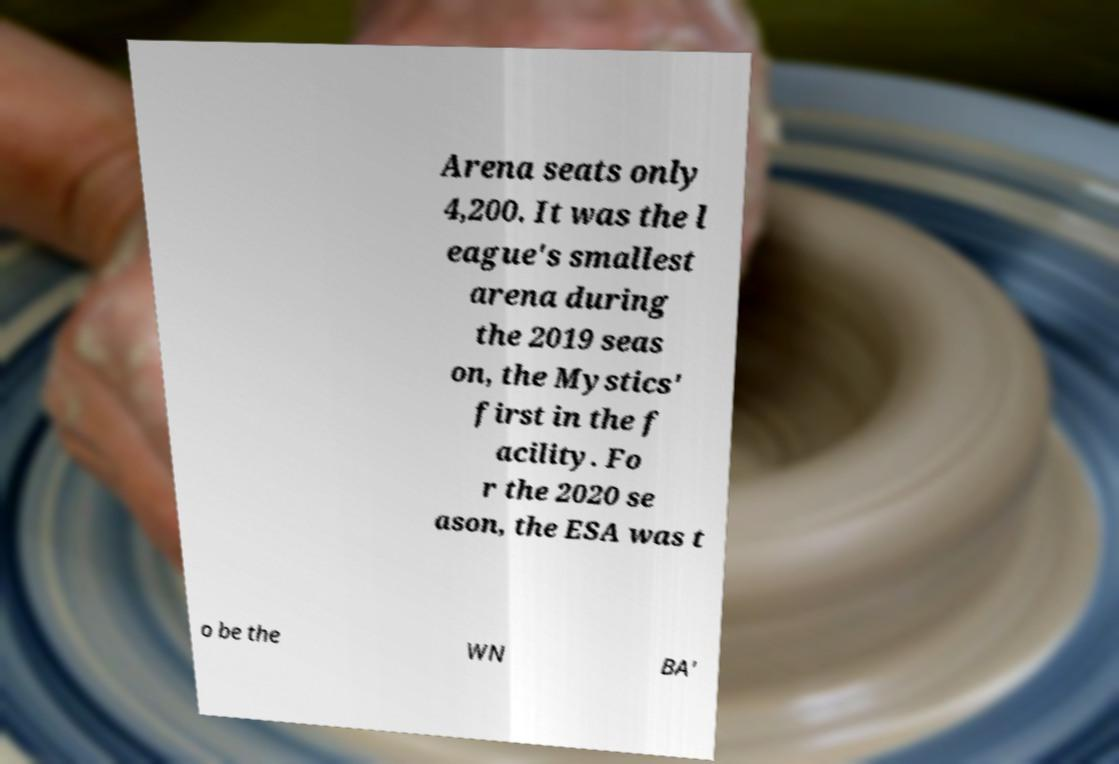Please identify and transcribe the text found in this image. Arena seats only 4,200. It was the l eague's smallest arena during the 2019 seas on, the Mystics' first in the f acility. Fo r the 2020 se ason, the ESA was t o be the WN BA' 